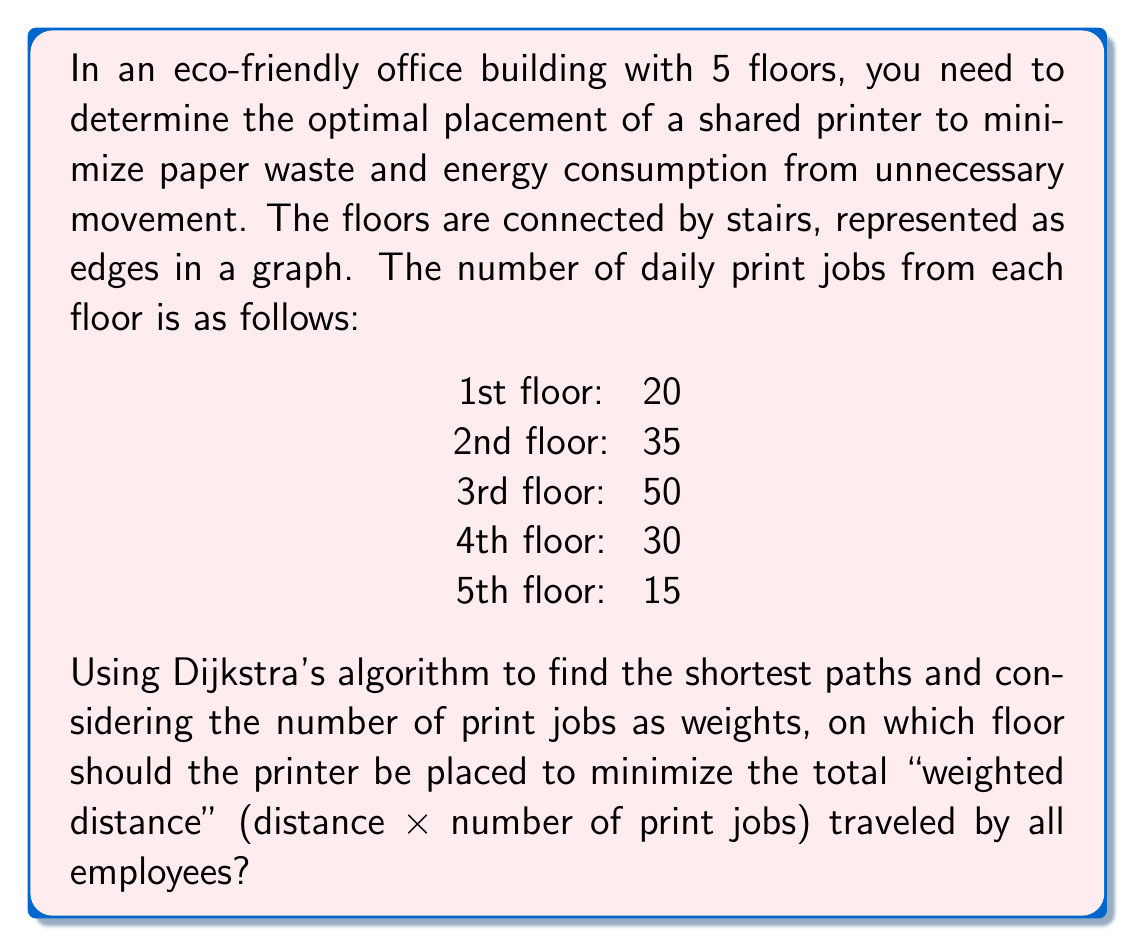Could you help me with this problem? Let's approach this step-by-step:

1) First, we need to create a graph representing the building:
   [asy]
   unitsize(1cm);
   for(int i=1; i<=5; ++i) {
     dot("F" + string(i), (0,i));
     if(i<5) draw((0,i)--(0,i+1));
   }
   label("20", (-0.5,1), W);
   label("35", (-0.5,2), W);
   label("50", (-0.5,3), W);
   label("30", (-0.5,4), W);
   label("15", (-0.5,5), W);
   [/asy]

2) We'll calculate the total weighted distance for placing the printer on each floor:

3) For the 1st floor:
   $$20 \times 0 + 35 \times 1 + 50 \times 2 + 30 \times 3 + 15 \times 4 = 325$$

4) For the 2nd floor:
   $$20 \times 1 + 35 \times 0 + 50 \times 1 + 30 \times 2 + 15 \times 3 = 225$$

5) For the 3rd floor:
   $$20 \times 2 + 35 \times 1 + 50 \times 0 + 30 \times 1 + 15 \times 2 = 175$$

6) For the 4th floor:
   $$20 \times 3 + 35 \times 2 + 50 \times 1 + 30 \times 0 + 15 \times 1 = 205$$

7) For the 5th floor:
   $$20 \times 4 + 35 \times 3 + 50 \times 2 + 30 \times 1 + 15 \times 0 = 325$$

8) The minimum total weighted distance is 175, corresponding to the 3rd floor.
Answer: 3rd floor 